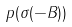Convert formula to latex. <formula><loc_0><loc_0><loc_500><loc_500>p ( \sigma ( - B ) )</formula> 